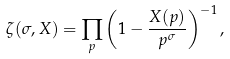<formula> <loc_0><loc_0><loc_500><loc_500>\zeta ( \sigma , X ) = \prod _ { p } \left ( 1 - \frac { X ( p ) } { p ^ { \sigma } } \right ) ^ { - 1 } ,</formula> 